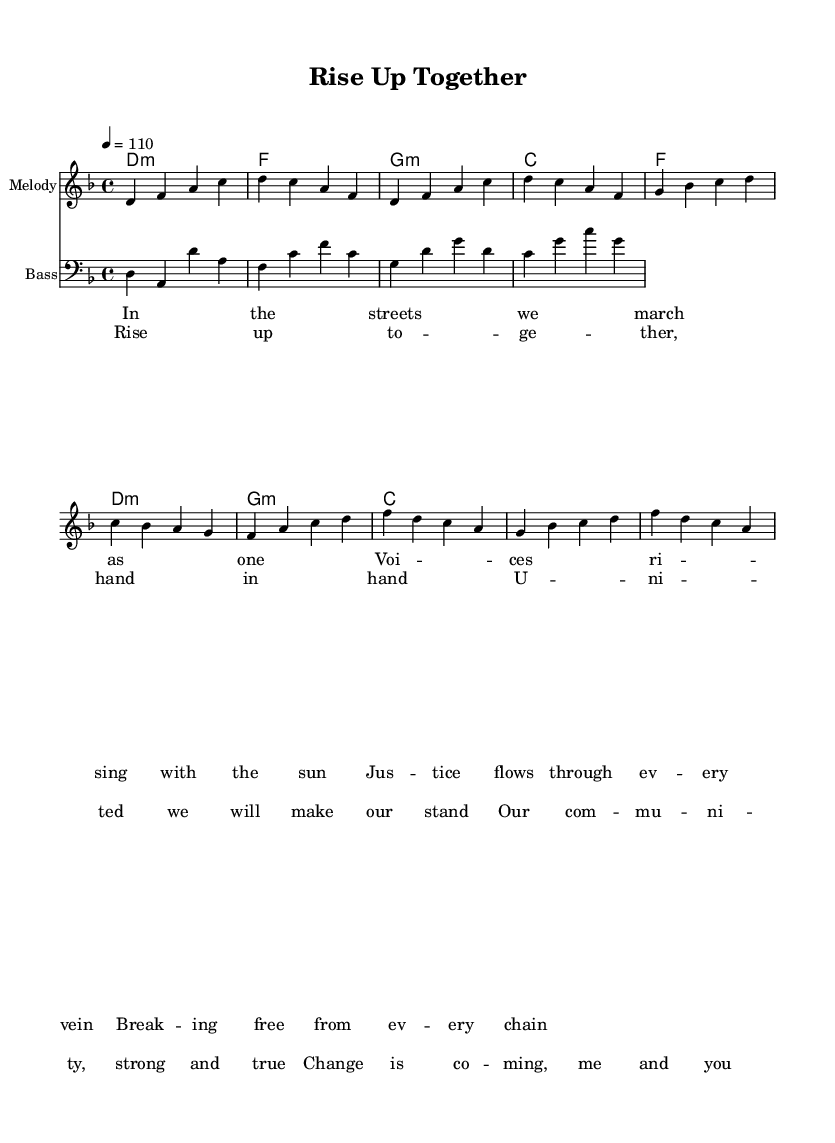What is the key signature of this music? The key signature is two flats, which indicates that the music is in D minor. D minor is related to F major, but since the melody prominently features D and its associated notes, it is identified as D minor.
Answer: D minor What is the time signature of this music? The time signature is indicated at the beginning of the staff and reads 4/4, meaning there are four beats in each measure. The "4" on the top signifies a quarter note gets one beat, which is standard for funk music as it provides a steady pulse for the groove.
Answer: 4/4 What is the tempo of this piece? The tempo marking is found above the staff and indicates a tempo of quarter note equals 110 beats per minute, commonly written as "4 = 110". This suggests a lively and energetic feel that is characteristic of funk music.
Answer: 110 How many lines are in the verse lyrics? The verse lyrics consist of four lines, each pairing with a corresponding line of melody. This is typical in song structure, allowing the lyrics to flow smoothly with the melodic phrasing.
Answer: 4 What is the primary chord used in the chorus? Examining the chord progression in the chorus section reveals that the main chord utilized is F major, which is the first chord of this progression. It sets a strong foundation for the uplifting message of the song.
Answer: F Which musical genre does this score belong to? The score is categorized under Funk, a genre known for its syncopated rhythms and strong bass lines, as well as its themes of social justice and community activism, which are emphasized in the lyrics of this anthem.
Answer: Funk What phrase describes the overall theme of the song? The song's lyrics celebrate unity and activism, as seen in the refrain, "Rise up together, hand in hand." This repeated message highlights the importance of community and working towards social change, which defines the song's purpose.
Answer: Unity and activism 